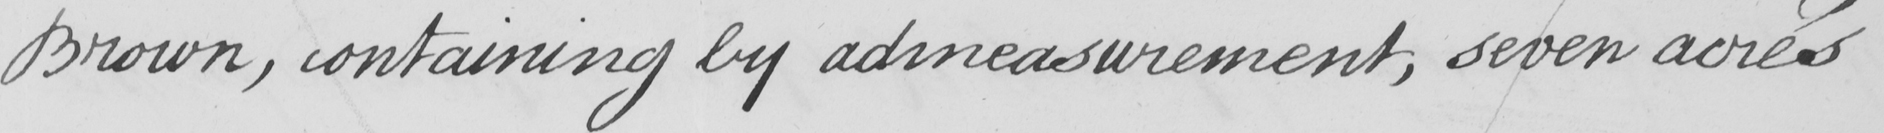Transcribe the text shown in this historical manuscript line. Brown , containing by admeasurement , seven acres 